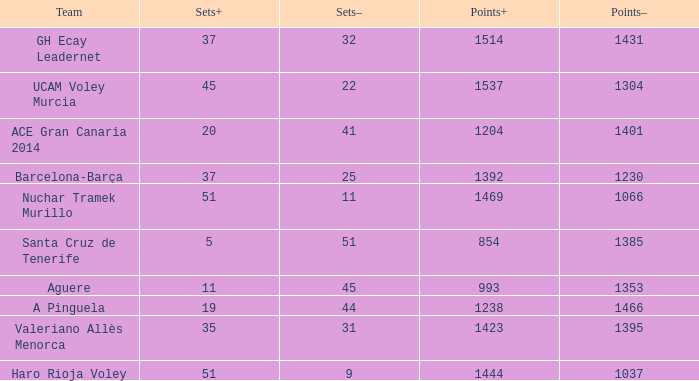What is the highest Points+ number when the Points- number is larger than 1385, a Sets+ number smaller than 37 and a Sets- number larger than 41? 1238.0. 